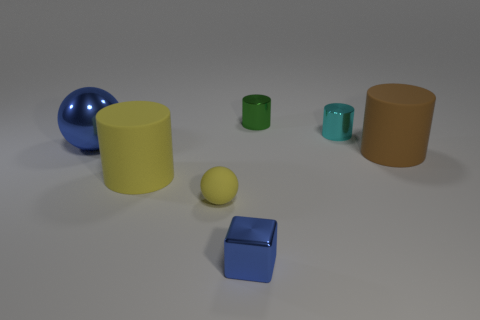Add 2 small cyan objects. How many objects exist? 9 Subtract all cylinders. How many objects are left? 3 Add 4 yellow spheres. How many yellow spheres exist? 5 Subtract 0 gray cylinders. How many objects are left? 7 Subtract all cyan matte things. Subtract all big brown cylinders. How many objects are left? 6 Add 6 blue things. How many blue things are left? 8 